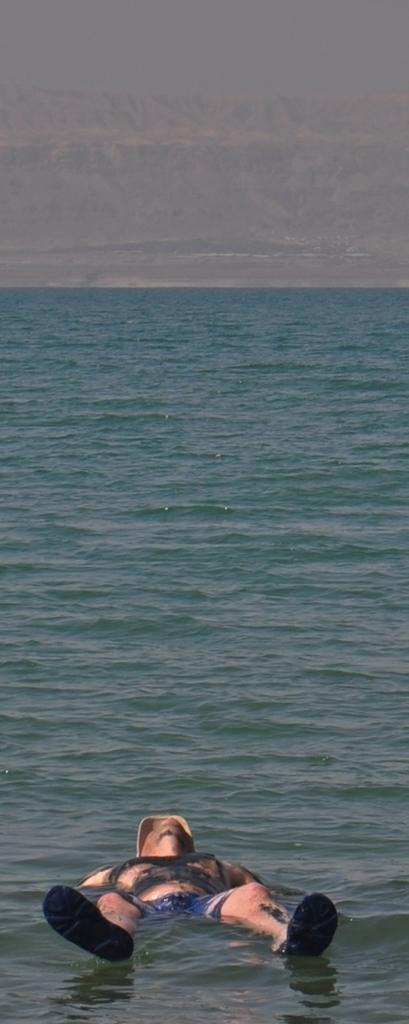What is the person in the image doing? The person is lying on the water in the image. What can be seen in the background of the image? The sky is visible in the background of the image. What type of account does the person in the image have with the representative on the ground? There is no representative or account mentioned in the image; it only shows a person lying on the water with the sky visible in the background. 